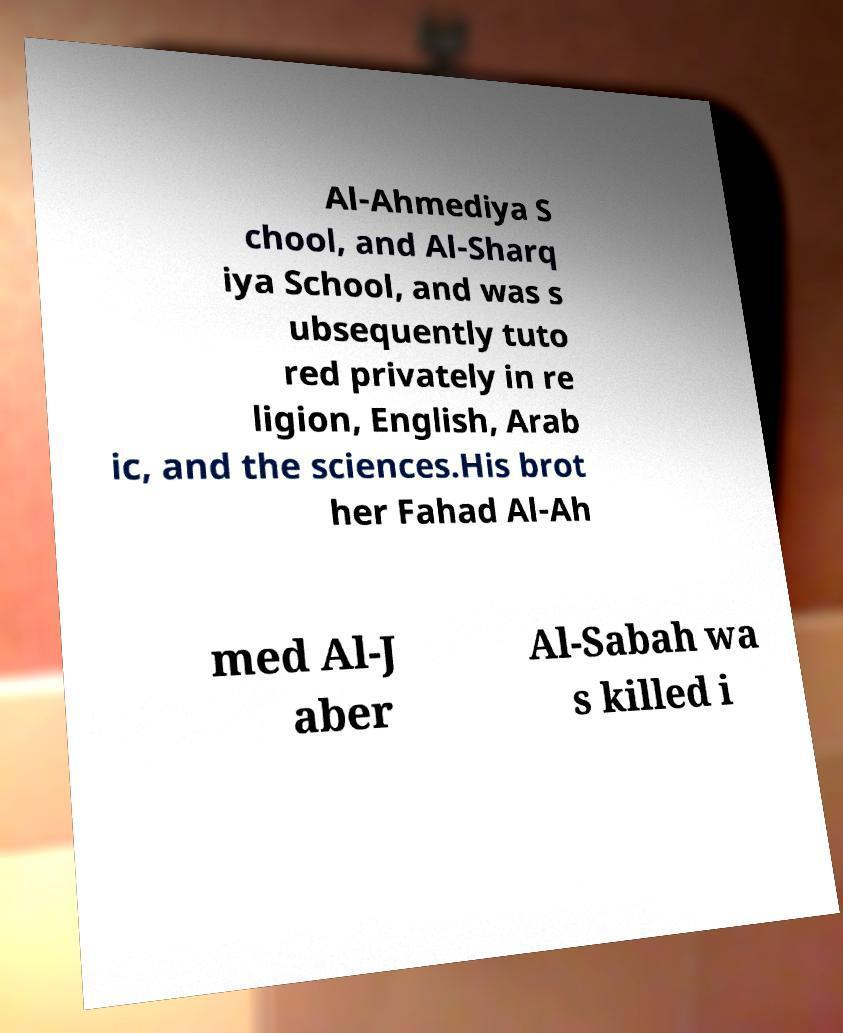Can you accurately transcribe the text from the provided image for me? Al-Ahmediya S chool, and Al-Sharq iya School, and was s ubsequently tuto red privately in re ligion, English, Arab ic, and the sciences.His brot her Fahad Al-Ah med Al-J aber Al-Sabah wa s killed i 